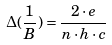Convert formula to latex. <formula><loc_0><loc_0><loc_500><loc_500>\Delta ( \frac { 1 } { B } ) = \frac { 2 \cdot e } { n \cdot h \cdot c }</formula> 